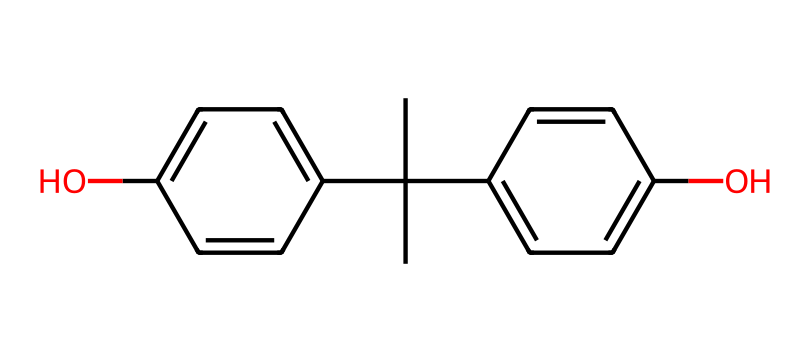What is the molecular formula of bisphenol A? To find the molecular formula, we can count the number of carbon (C), hydrogen (H), and oxygen (O) atoms present in the SMILES representation. There are 15 carbons, 16 hydrogens, and 2 oxygens. Thus, the molecular formula is C15H16O2.
Answer: C15H16O2 How many hydroxyl groups are present in bisphenol A? By examining the structure, we see that there are two hydroxyl groups (–OH) attached to the benzene rings. Each –OH indicates a hydroxyl group.
Answer: 2 What type of bonding is primarily present in bisphenol A? The main type of bonding in this chemical is covalent bonding, which is evident from the shared electrons between the carbon atoms in the structure.
Answer: covalent What is the significance of the two phenolic rings in bisphenol A? The two phenolic rings are crucial as they contribute to the chemical's properties, such as its ability to form polycarbonate plastics and its interaction with hormones.
Answer: plastic properties Which atom is responsible for the unique properties of bisphenol A as a plasticizer? The carbon atoms extensively bonded in the structure lead to a rigid yet flexible arrangement, facilitating the material's use as a plasticizer in various products.
Answer: carbon How many rings are present in the bisphenol A structure? The structure contains two aromatic rings, identified by the presence of alternating double bonds within the cyclic arrangements, which is typical of phenolic compounds.
Answer: 2 